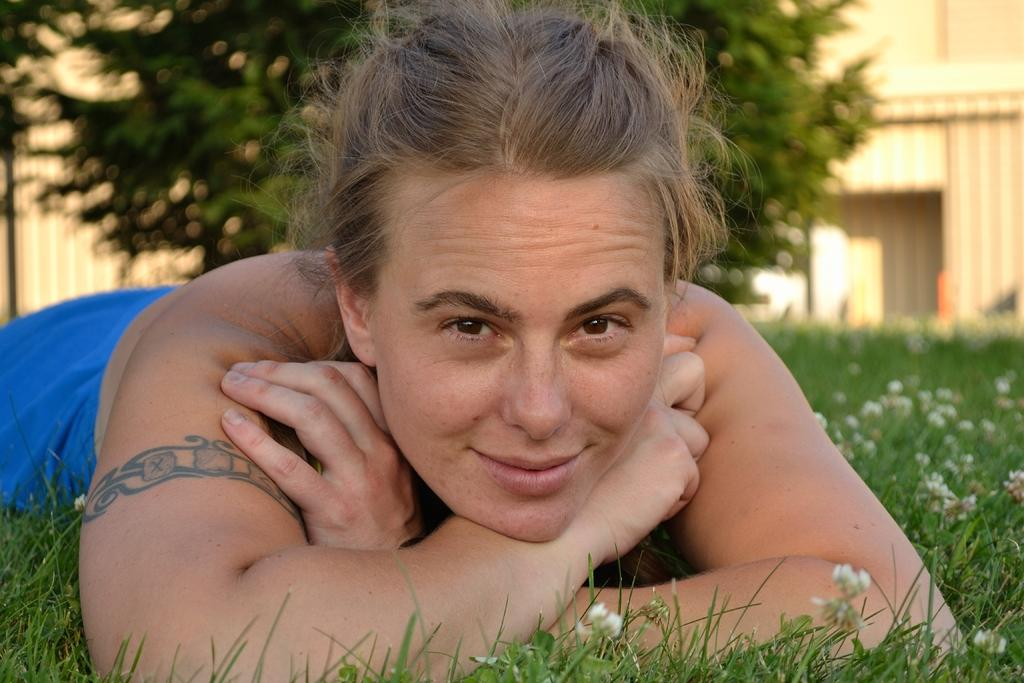What is the woman doing in the image? The woman is laying on the ground in the image. What is the woman's facial expression in the image? The woman is smiling in the image. What type of surface is the woman laying on? There is grass on the ground in the image. What can be seen in the background of the image? There are trees in the background of the image. Can you see any stars in the image? There are no stars visible in the image. Are there any fairies flying around the woman in the image? There are no fairies present in the image. 